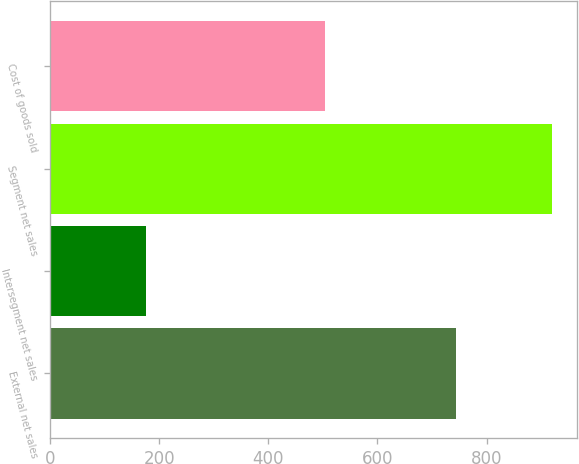<chart> <loc_0><loc_0><loc_500><loc_500><bar_chart><fcel>External net sales<fcel>Intersegment net sales<fcel>Segment net sales<fcel>Cost of goods sold<nl><fcel>744.9<fcel>175.7<fcel>920.6<fcel>504.3<nl></chart> 